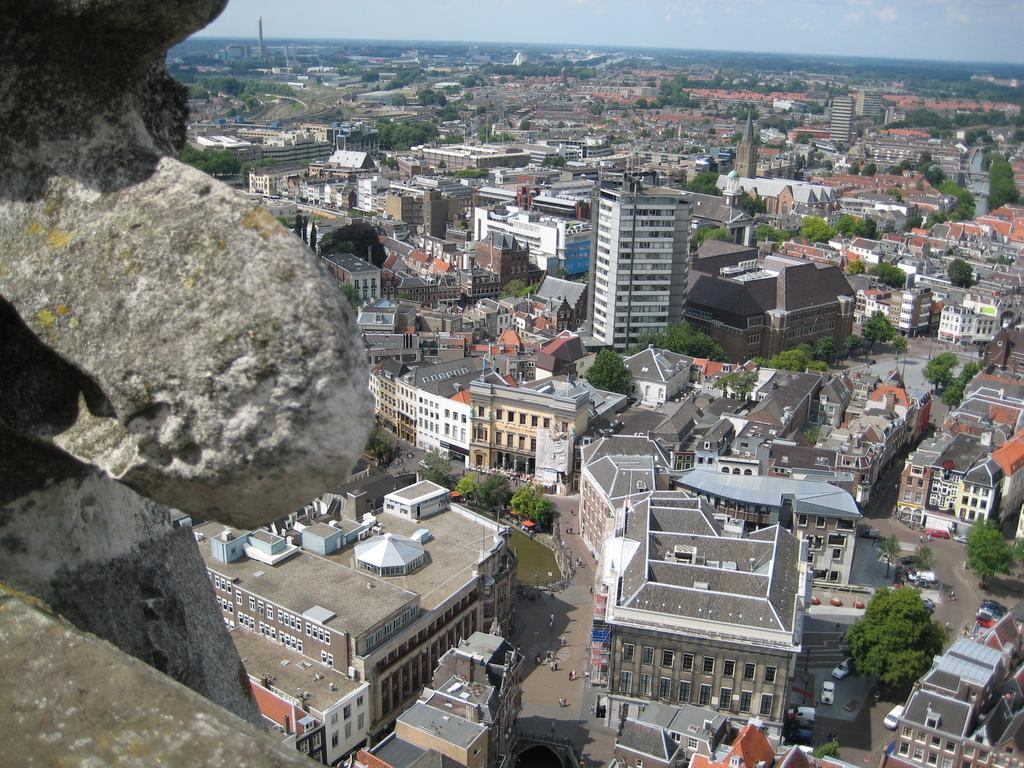What type of natural elements are present in the image? There is a group of trees in the image. What type of man-made structures can be seen in the image? There are buildings in the image. Where is the rock located in the image? The rock is on the left side of the image. What is visible at the top of the image? The sky is visible at the top of the image. How many dolls are sitting on the rock in the image? There are no dolls present in the image; it features a rock, trees, buildings, and the sky. Is there any dust visible on the buildings in the image? The image does not provide enough detail to determine if there is dust on the buildings. 